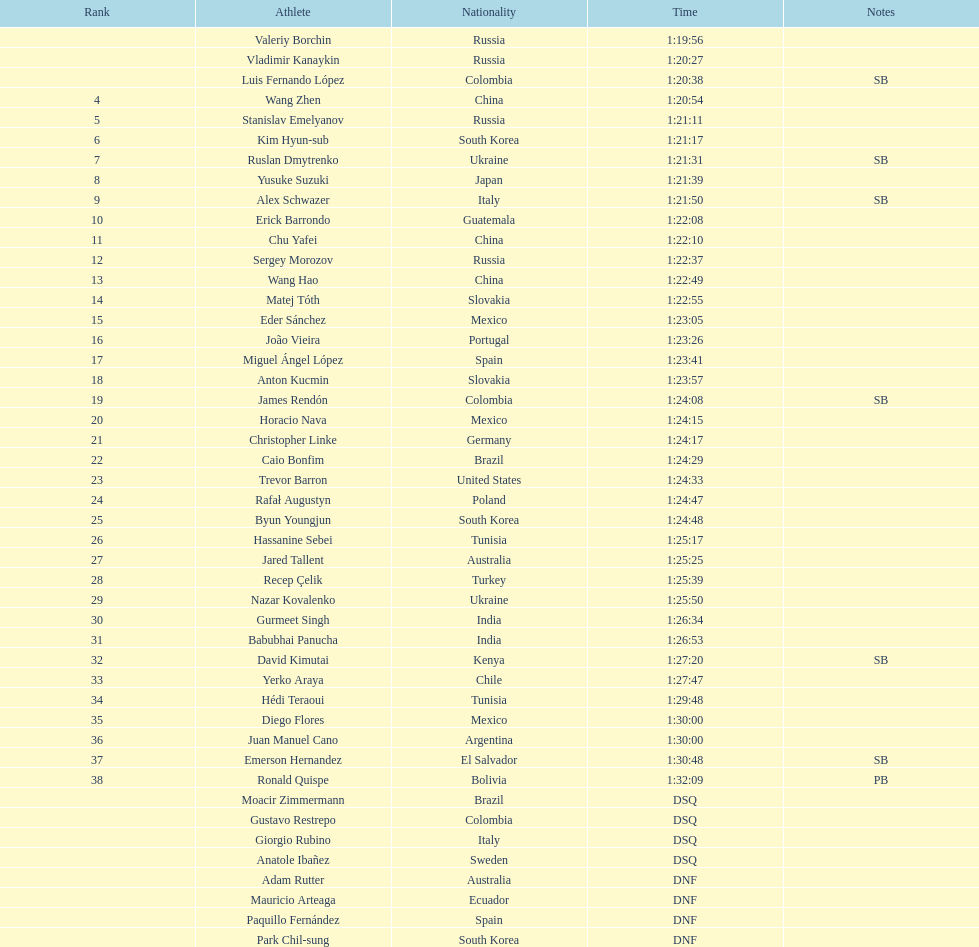How many contestants were from russia? 4. 